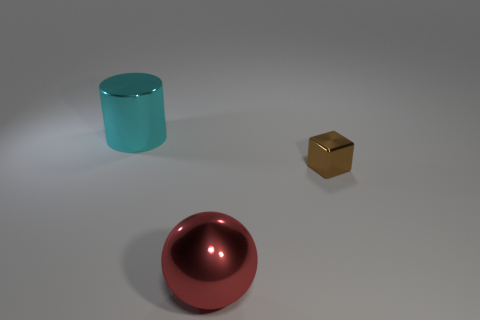What color is the large sphere that is the same material as the cyan cylinder?
Give a very brief answer. Red. Is the number of tiny metal blocks less than the number of big shiny things?
Ensure brevity in your answer.  Yes. There is a object that is both left of the brown metal block and behind the large red object; what is it made of?
Provide a short and direct response. Metal. There is a thing behind the small brown cube; are there any things that are on the right side of it?
Provide a succinct answer. Yes. How many big spheres have the same color as the metal block?
Your answer should be very brief. 0. Are the big cylinder and the small cube made of the same material?
Offer a very short reply. Yes. Are there any tiny shiny things right of the metal cube?
Your answer should be very brief. No. What material is the big object right of the large shiny object that is behind the shiny sphere made of?
Ensure brevity in your answer.  Metal. Do the tiny metal block and the cylinder have the same color?
Your answer should be compact. No. There is a metal thing that is left of the shiny cube and in front of the metallic cylinder; what is its color?
Your answer should be compact. Red. 